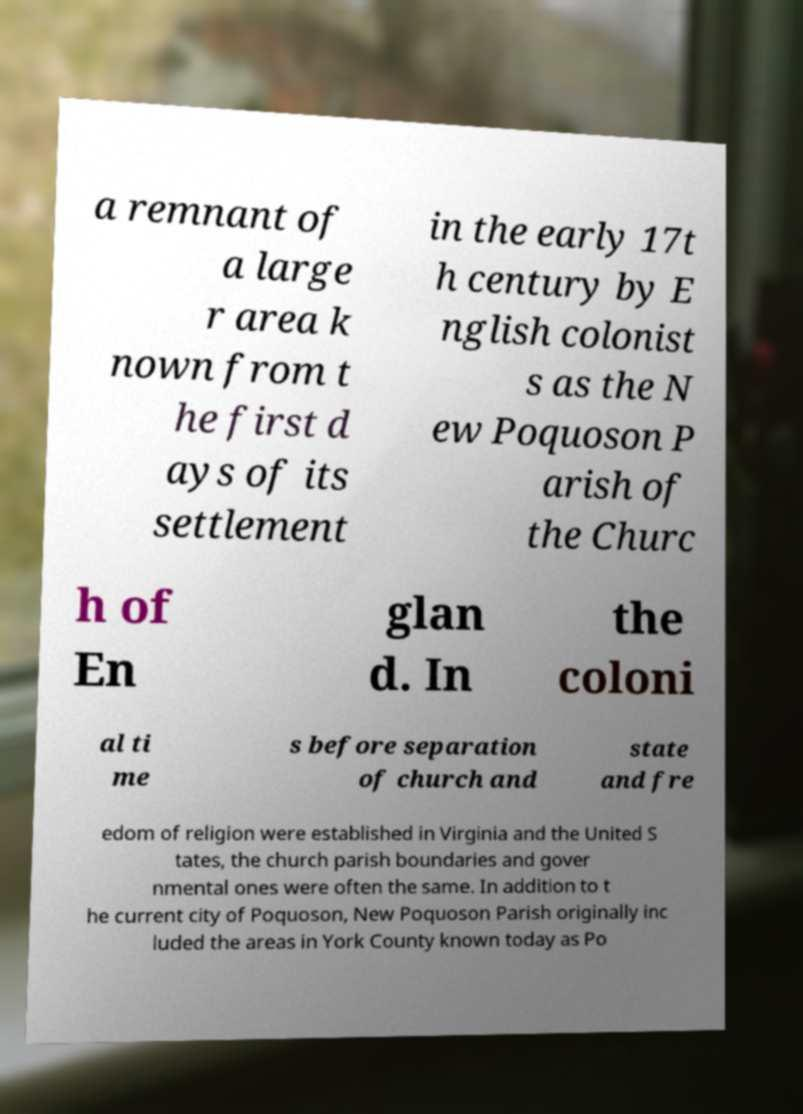Can you accurately transcribe the text from the provided image for me? a remnant of a large r area k nown from t he first d ays of its settlement in the early 17t h century by E nglish colonist s as the N ew Poquoson P arish of the Churc h of En glan d. In the coloni al ti me s before separation of church and state and fre edom of religion were established in Virginia and the United S tates, the church parish boundaries and gover nmental ones were often the same. In addition to t he current city of Poquoson, New Poquoson Parish originally inc luded the areas in York County known today as Po 